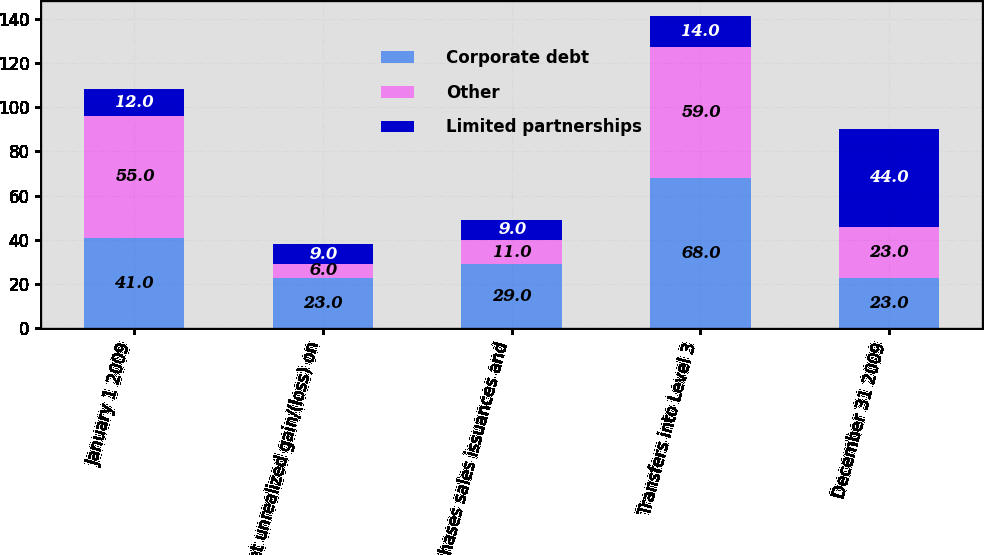Convert chart. <chart><loc_0><loc_0><loc_500><loc_500><stacked_bar_chart><ecel><fcel>January 1 2009<fcel>Net unrealized gain/(loss) on<fcel>Purchases sales issuances and<fcel>Transfers into Level 3<fcel>December 31 2009<nl><fcel>Corporate debt<fcel>41<fcel>23<fcel>29<fcel>68<fcel>23<nl><fcel>Other<fcel>55<fcel>6<fcel>11<fcel>59<fcel>23<nl><fcel>Limited partnerships<fcel>12<fcel>9<fcel>9<fcel>14<fcel>44<nl></chart> 